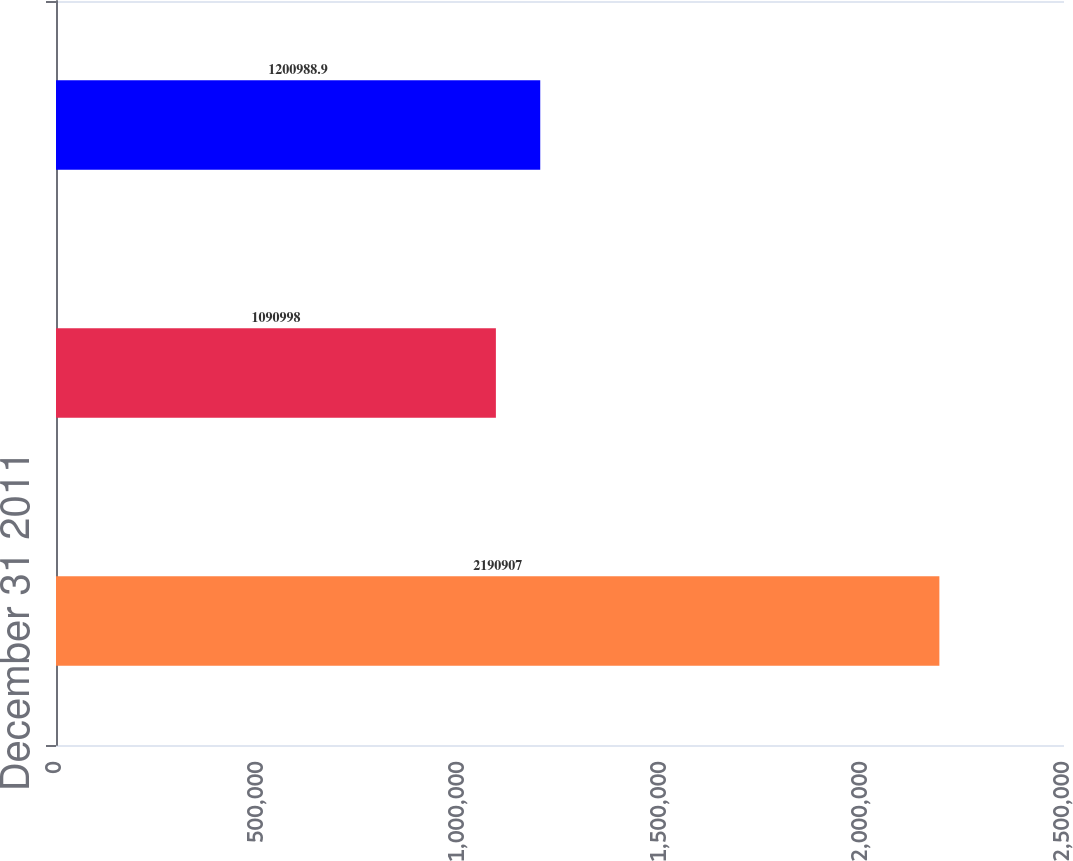<chart> <loc_0><loc_0><loc_500><loc_500><bar_chart><fcel>December 31 2011<fcel>Exercised<fcel>December 31 2012 (1)<nl><fcel>2.19091e+06<fcel>1.091e+06<fcel>1.20099e+06<nl></chart> 